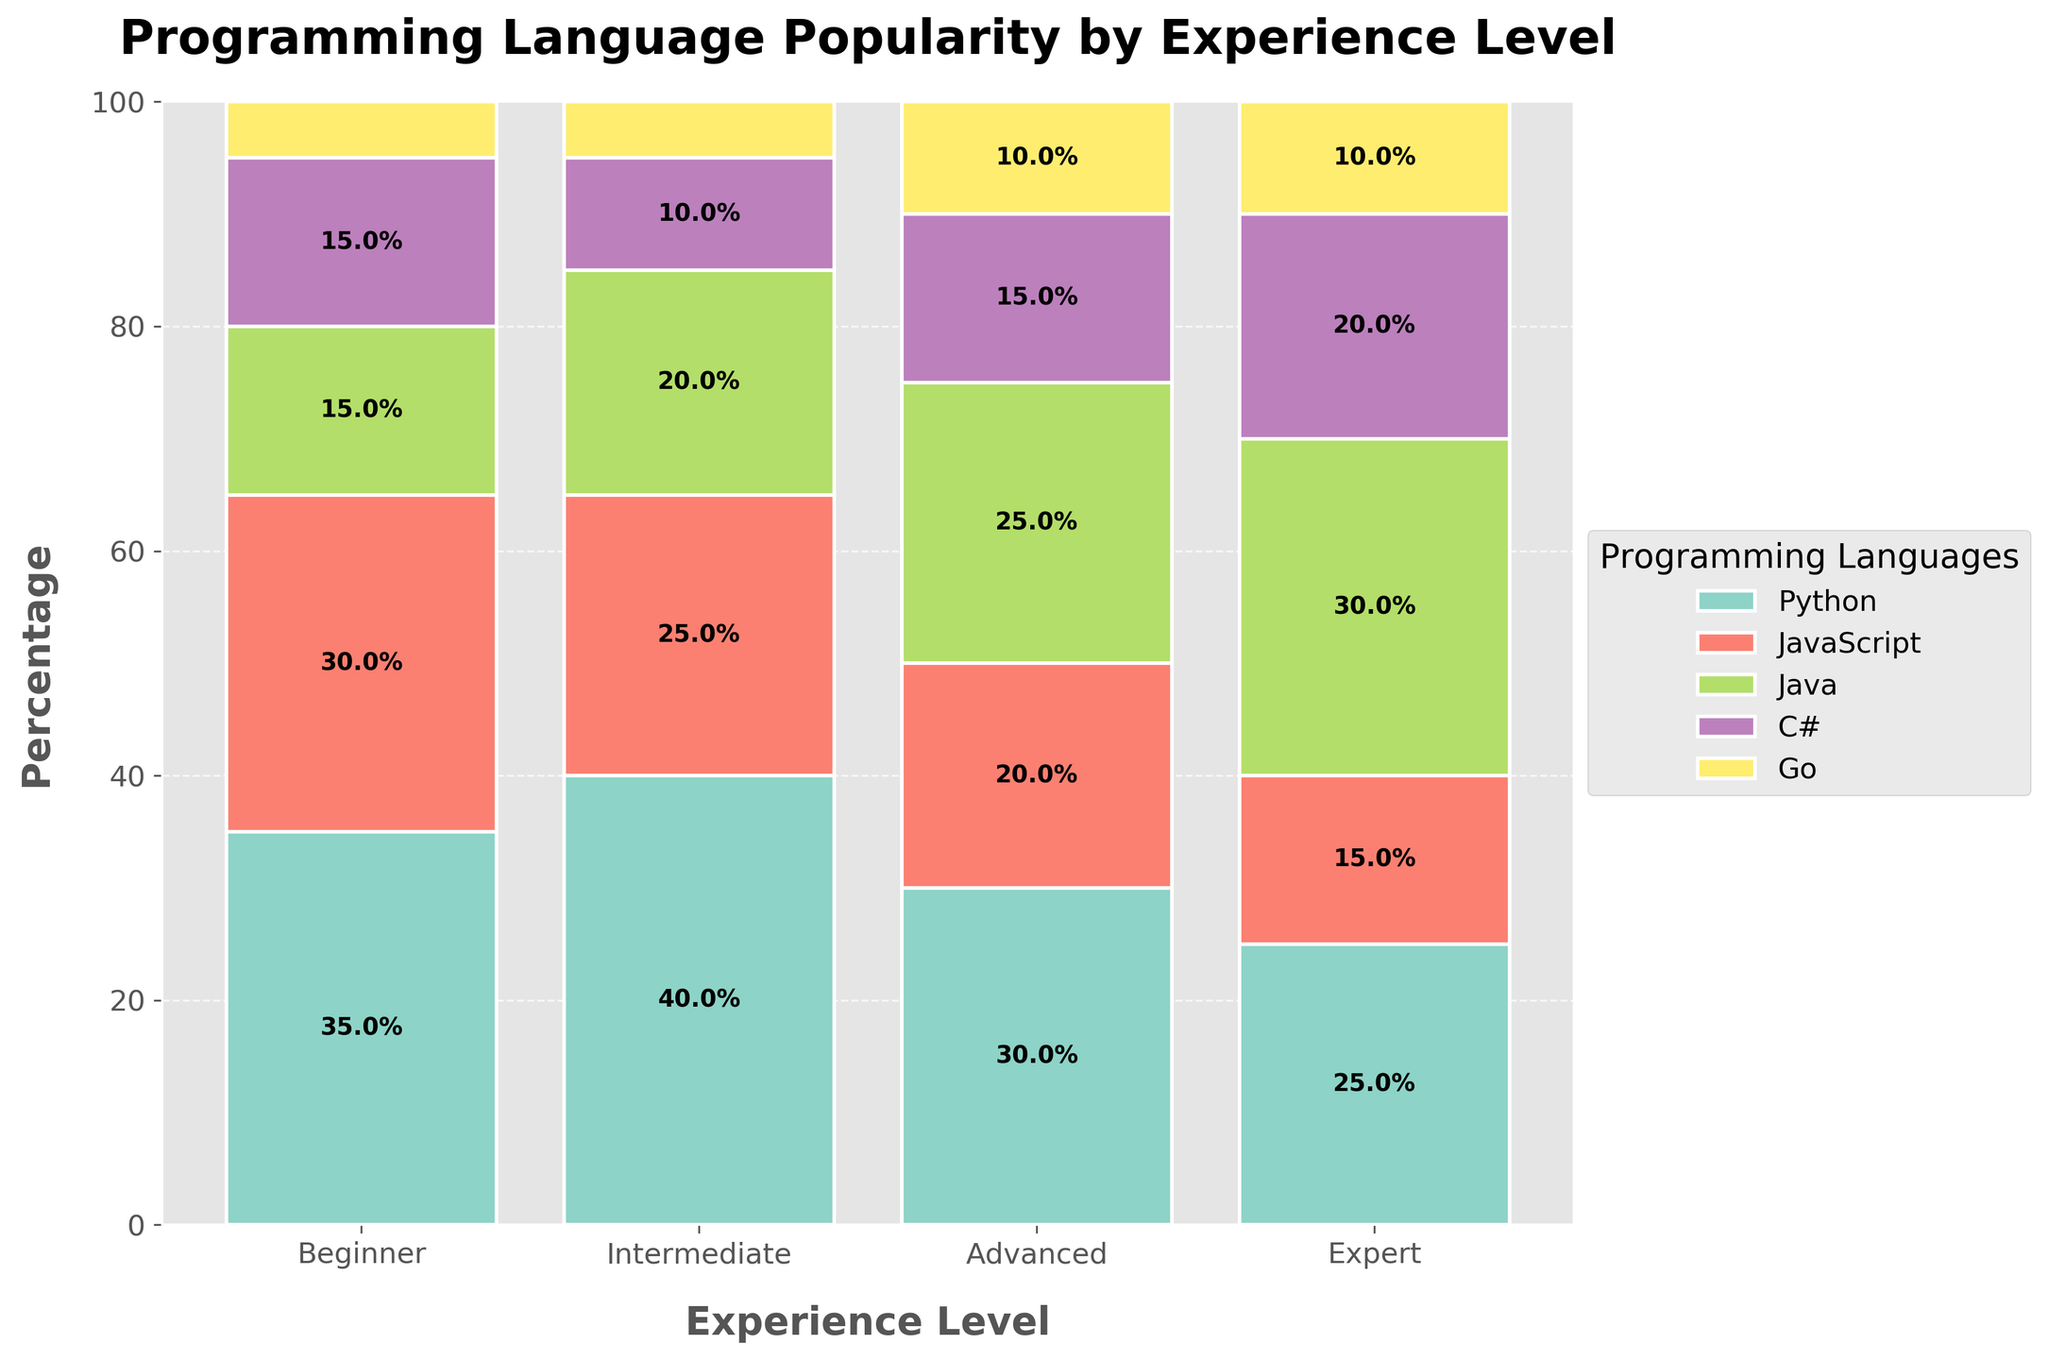What's the title of the plot? The title is displayed at the top of the plot, indicating what the visual is about. By looking at the top of the figure, you can read the title: "Programming Language Popularity by Experience Level".
Answer: Programming Language Popularity by Experience Level What's the percentage of Python users among Beginners? Find the "Beginner" bar, look at the segment representing Python, and read the percentage label inside or near this segment. The label inside the green segment is 35%.
Answer: 35% Which language has the smallest percentage of users in the Expert category? Locate the "Expert" bar and compare all segments to identify the one with the smallest size. The smallest segment for Experts is JavaScript, which seems 15%.
Answer: JavaScript What is the combined percentage of C# and Go for Advanced developers? Find the "Advanced" bar, read the percentage for C# and Go, and sum them up: 15% (C#) + 10% (Go).
Answer: 25% Which language sees the most consistent usage across all experience levels? Review the heights of the segments for each language across all experience levels, and look for the one that shows minimal variation. Python has fairly consistent usage: Beginner (35%), Intermediate (40%), Advanced (30%), Expert (25%).
Answer: Python Does the percentage of Java users increase or decrease with experience level? Track the Java segments across different experience levels from Beginner to Expert. The percentages are: Beginner (15%), Intermediate (20%), Advanced (25%), Expert (30%). The usage increases as experience level rises.
Answer: Increase How does the percentage of C# users in the Intermediate group compare to the Beginner group? Compare the C# segment heights for Intermediate and Beginner categories. Intermediate shows 10%, and Beginner shows 15%. 10% is less than 15%.
Answer: Less What percentage of total Go users are Experts? Calculate the percentage of Experts for Go by reading the percentage from the "Expert" category: 10%. Go's total percentage distribution includes Beginners (5%), Intermediates (5%), Advanced (10%), Experts (10%). Sum these (30%), then 10/30 = 33.3%.
Answer: 33.3% Which experience level has the highest percentage of JavaScript users? Compare all JavaScript segments across experience levels and identify the highest: Beginners have the largest segment with 30%.
Answer: Beginner 